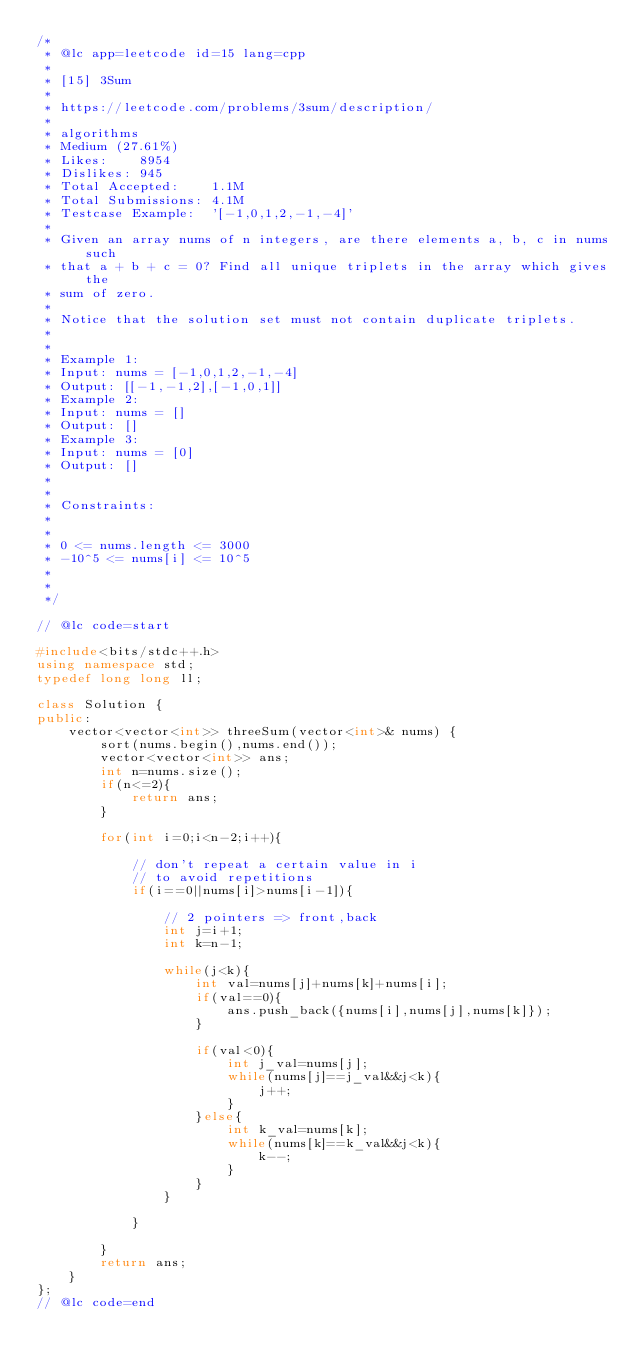<code> <loc_0><loc_0><loc_500><loc_500><_C++_>/*
 * @lc app=leetcode id=15 lang=cpp
 *
 * [15] 3Sum
 *
 * https://leetcode.com/problems/3sum/description/
 *
 * algorithms
 * Medium (27.61%)
 * Likes:    8954
 * Dislikes: 945
 * Total Accepted:    1.1M
 * Total Submissions: 4.1M
 * Testcase Example:  '[-1,0,1,2,-1,-4]'
 *
 * Given an array nums of n integers, are there elements a, b, c in nums such
 * that a + b + c = 0? Find all unique triplets in the array which gives the
 * sum of zero.
 * 
 * Notice that the solution set must not contain duplicate triplets.
 * 
 * 
 * Example 1:
 * Input: nums = [-1,0,1,2,-1,-4]
 * Output: [[-1,-1,2],[-1,0,1]]
 * Example 2:
 * Input: nums = []
 * Output: []
 * Example 3:
 * Input: nums = [0]
 * Output: []
 * 
 * 
 * Constraints:
 * 
 * 
 * 0 <= nums.length <= 3000
 * -10^5 <= nums[i] <= 10^5
 * 
 * 
 */

// @lc code=start

#include<bits/stdc++.h>
using namespace std;
typedef long long ll;

class Solution {
public:
    vector<vector<int>> threeSum(vector<int>& nums) {
        sort(nums.begin(),nums.end());
        vector<vector<int>> ans;
        int n=nums.size();
        if(n<=2){
            return ans;
        }

        for(int i=0;i<n-2;i++){

            // don't repeat a certain value in i
            // to avoid repetitions
            if(i==0||nums[i]>nums[i-1]){

                // 2 pointers => front,back
                int j=i+1;
                int k=n-1;

                while(j<k){
                    int val=nums[j]+nums[k]+nums[i];
                    if(val==0){
                        ans.push_back({nums[i],nums[j],nums[k]});
                    }

                    if(val<0){
                        int j_val=nums[j];
                        while(nums[j]==j_val&&j<k){
                            j++;
                        }
                    }else{
                        int k_val=nums[k];
                        while(nums[k]==k_val&&j<k){
                            k--;
                        }
                    }
                }

            }

        }
        return ans;
    }
};
// @lc code=end

</code> 